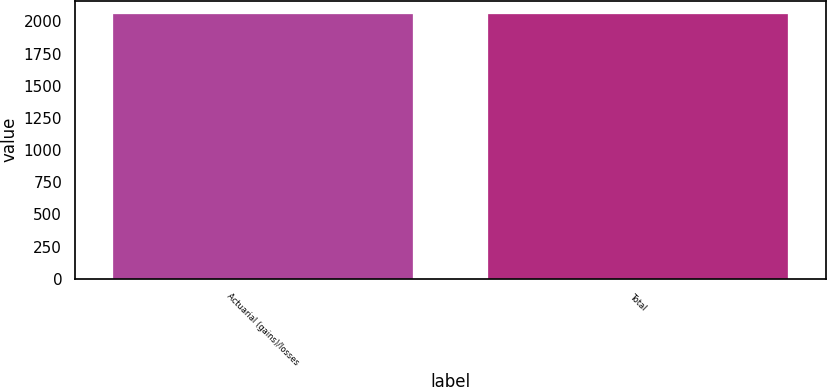Convert chart. <chart><loc_0><loc_0><loc_500><loc_500><bar_chart><fcel>Actuarial (gains)/losses<fcel>Total<nl><fcel>2058<fcel>2058.1<nl></chart> 